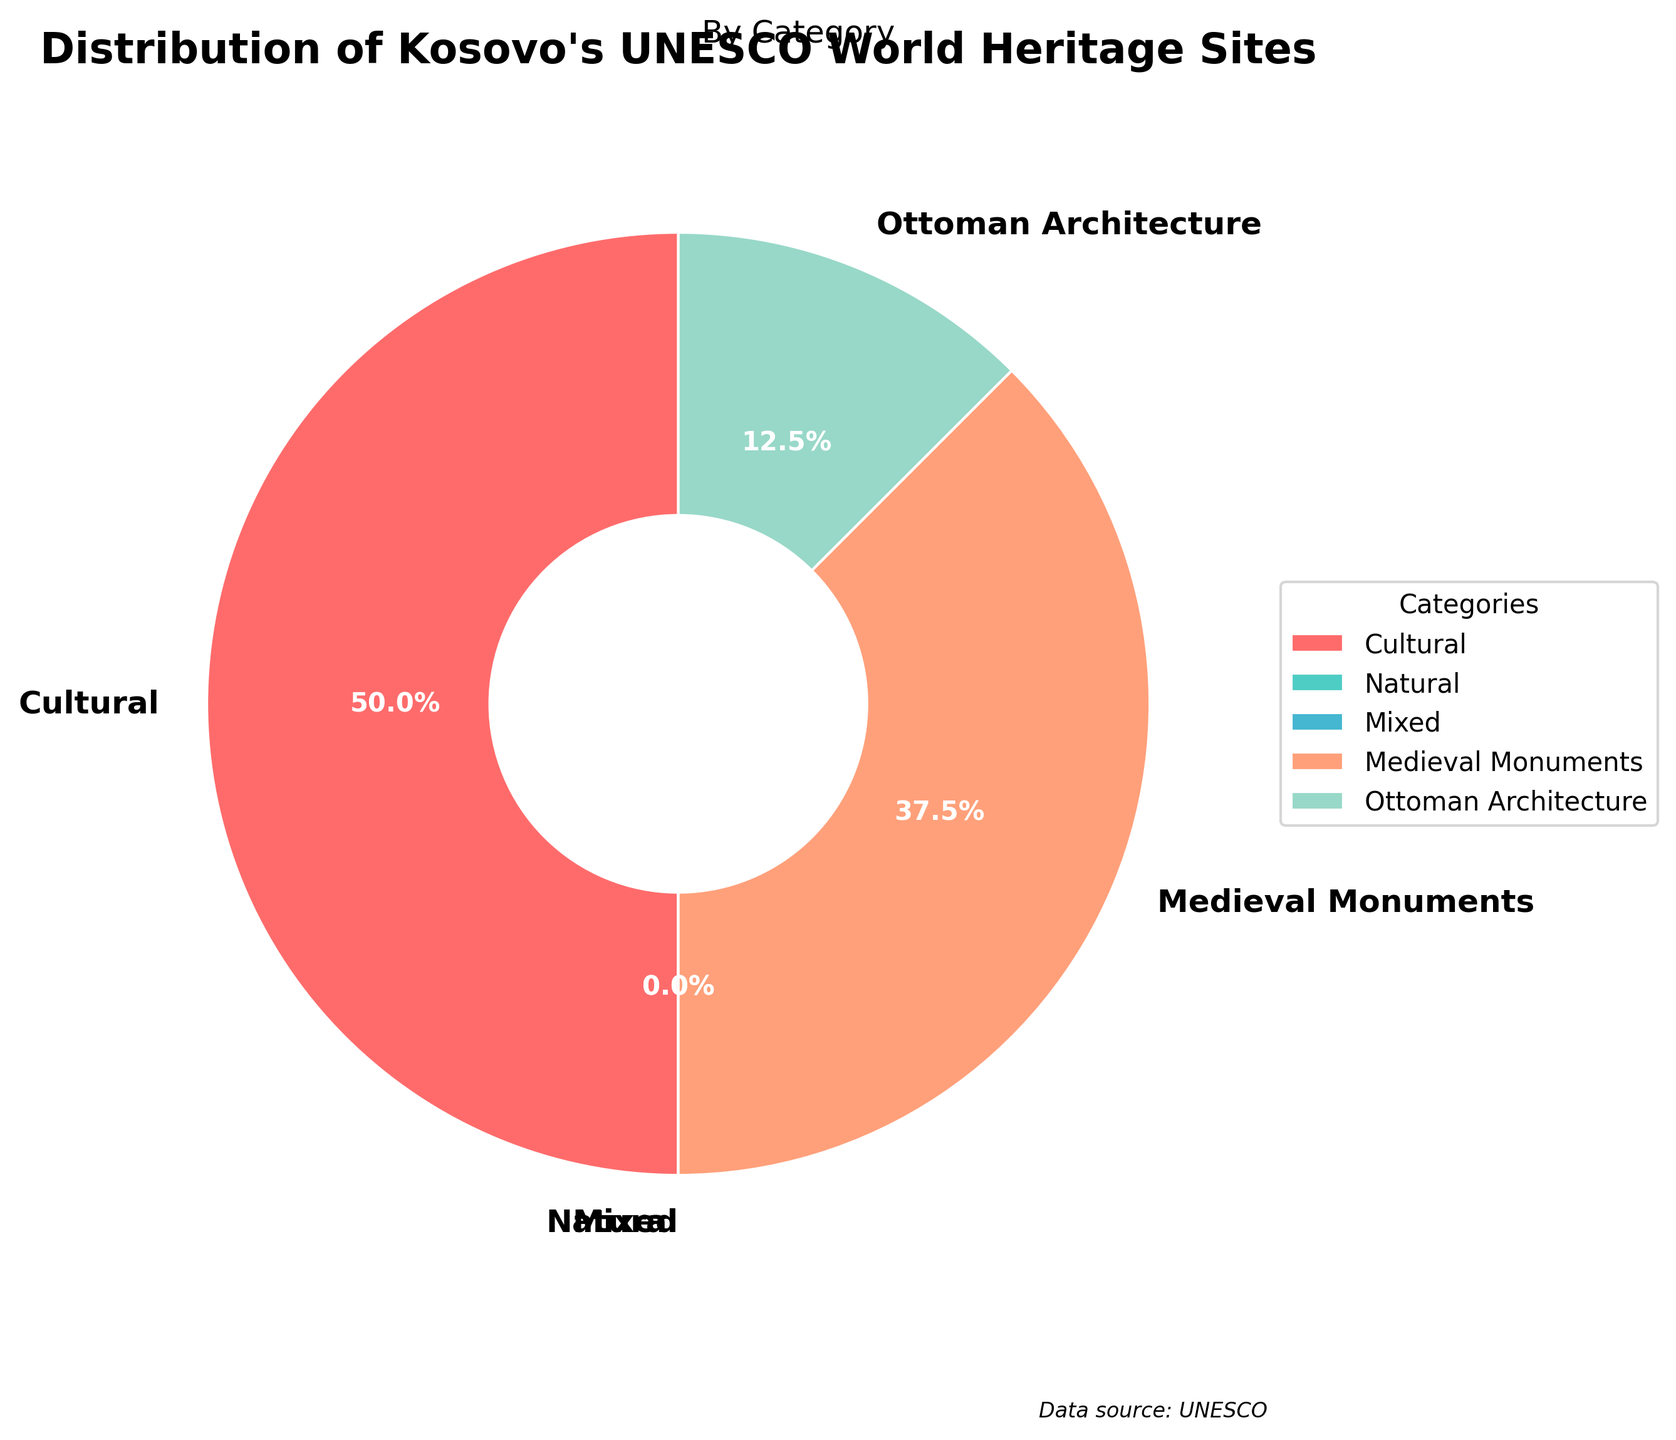What category has the highest number of UNESCO World Heritage Sites in Kosovo? The pie chart shows that the 'Cultural' category occupies the largest sector. Thus, the 'Cultural' category has the highest number of sites.
Answer: Cultural How many more Cultural sites are there compared to Ottoman Architecture sites? The number of Cultural sites is 4, and the number of Ottoman Architecture sites is 1. So, the difference is 4 - 1.
Answer: 3 What percentage of UNESCO World Heritage Sites in Kosovo fall under the Medieval Monuments category? The slice representing Medieval Monuments on the pie chart is labeled as having 3 sites out of a total of 8 (4 Cultural + 3 Medieval Monuments + 1 Ottoman Architecture). The percentage is (3/8) * 100%.
Answer: 37.5% Which category has the smallest representation in the pie chart? The pie chart segments show that both 'Natural' and 'Mixed' categories have 0 sites, making them the smallest representations.
Answer: Natural, Mixed Are there any categories with an equal number of UNESCO World Heritage Sites? Only the 'Natural' and 'Mixed' categories have the same number of sites, which is 0. The other categories have different counts.
Answer: Yes, Natural and Mixed What is the combined total number of sites under Medieval Monuments and Ottoman Architecture? The number of Medieval Monuments sites is 3, and the number of Ottoman Architecture sites is 1. Combined, it is 3 + 1.
Answer: 4 What is the comparative difference in the number of sites between the highest and the lowest categories? The highest category has 4 sites (Cultural), and the lowest categories (Natural and Mixed) have 0 sites. The comparative difference is 4 - 0.
Answer: 4 By what visual indicator can you identify the Cultural slice on the pie chart? The 'Cultural' slice can be identified by its color, which is red. Additionally, it's the largest segment in the pie chart.
Answer: Red and largest segment If we clustered all categories except Cultural together, what would be the combined percentage representation? The Cultural category alone represents 4 out of 8 sites (50%). The remaining categories thus represent 1 - 0.5 = 0.5 or 50%.
Answer: 50% Which categories are not present in Kosovo's UNESCO World Heritage Sites? The pie chart shows 0 sites for both the 'Natural' and 'Mixed' categories, indicating no presence of these types of sites.
Answer: Natural, Mixed 